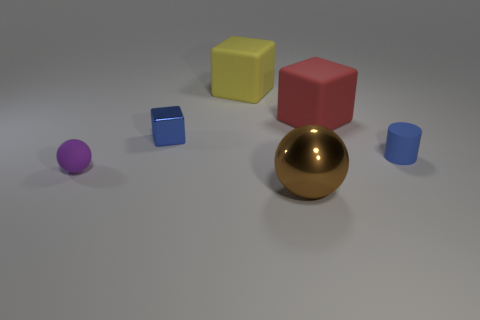Subtract all big red cubes. How many cubes are left? 2 Add 1 blue cylinders. How many objects exist? 7 Subtract all brown balls. How many balls are left? 1 Subtract all balls. How many objects are left? 4 Subtract 1 blocks. How many blocks are left? 2 Add 4 tiny purple matte spheres. How many tiny purple matte spheres exist? 5 Subtract 0 cyan blocks. How many objects are left? 6 Subtract all cyan cubes. Subtract all gray cylinders. How many cubes are left? 3 Subtract all tiny purple rubber spheres. Subtract all large red cubes. How many objects are left? 4 Add 3 purple spheres. How many purple spheres are left? 4 